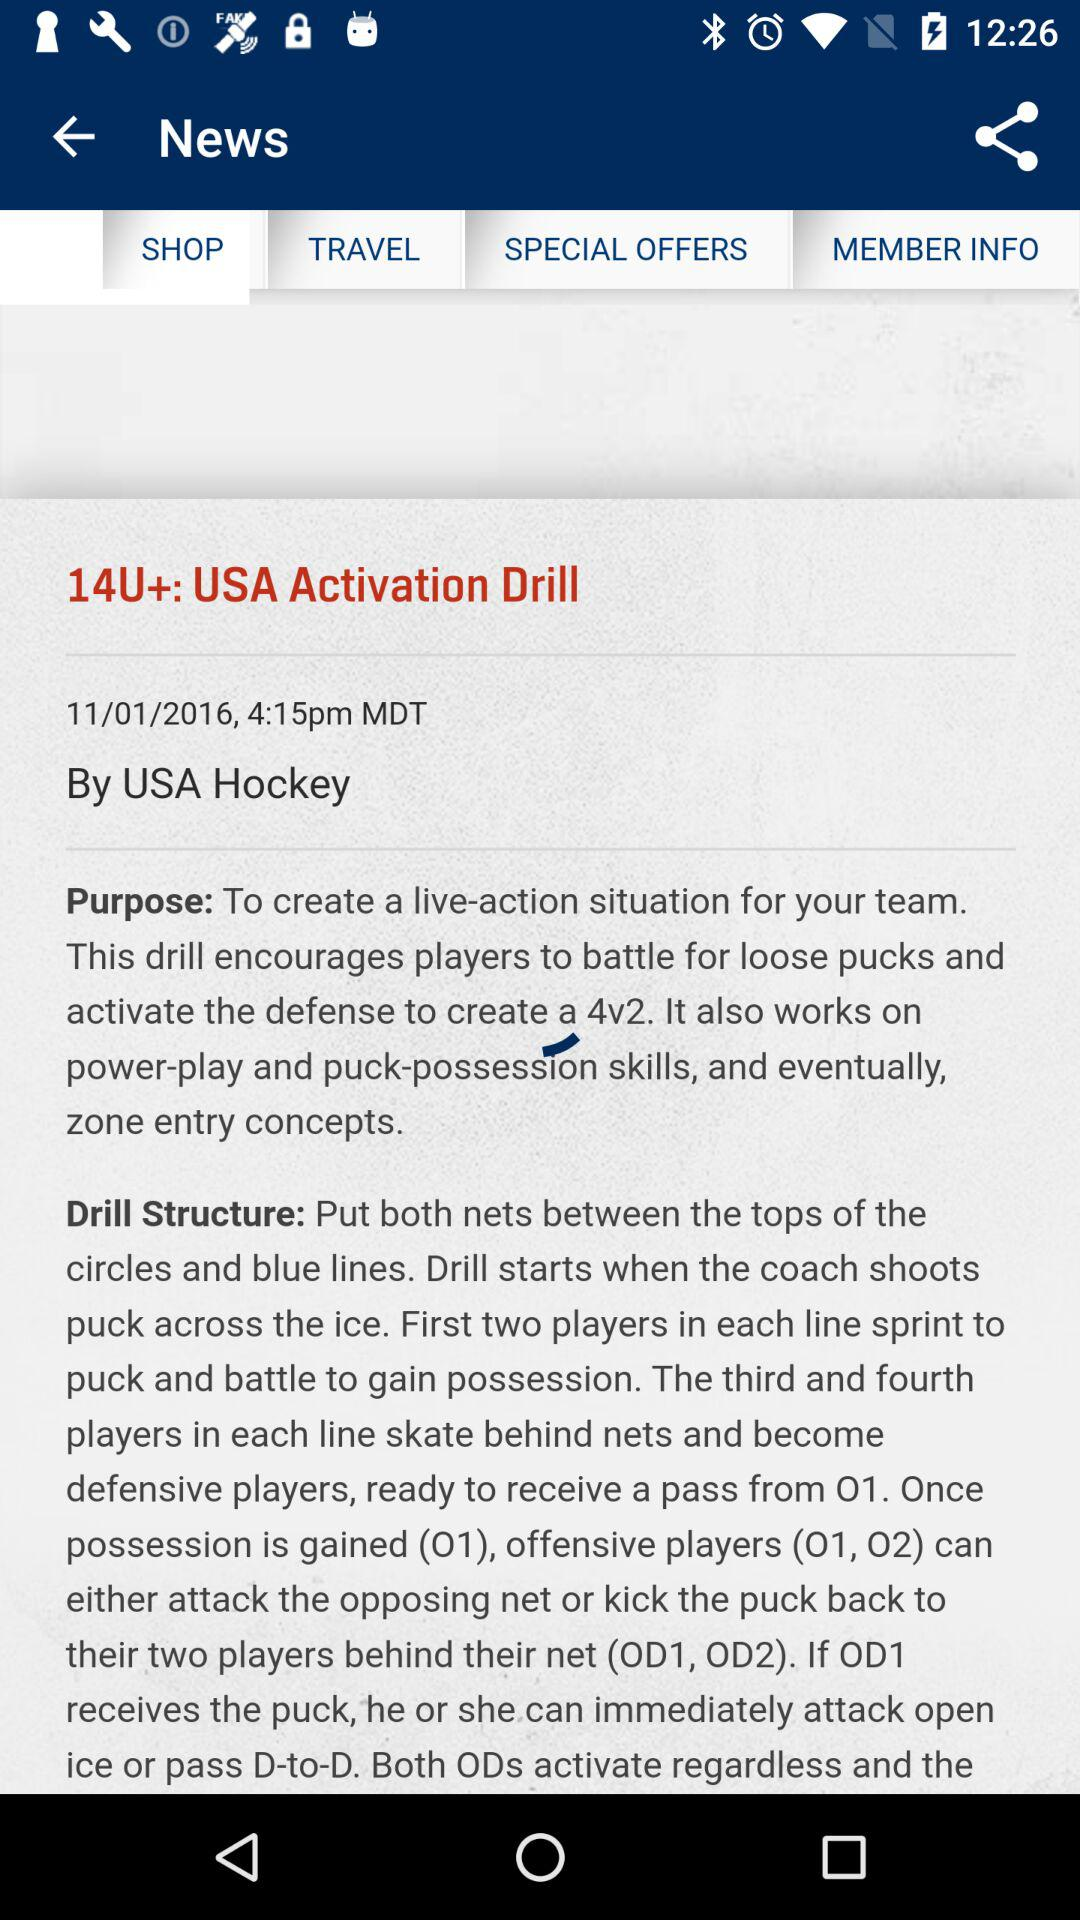On what date was the article posted? The article was posted on 11/01/2016. 